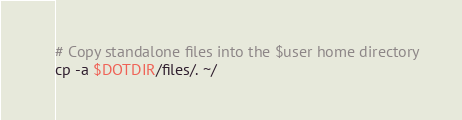Convert code to text. <code><loc_0><loc_0><loc_500><loc_500><_Bash_># Copy standalone files into the $user home directory
cp -a $DOTDIR/files/. ~/
</code> 